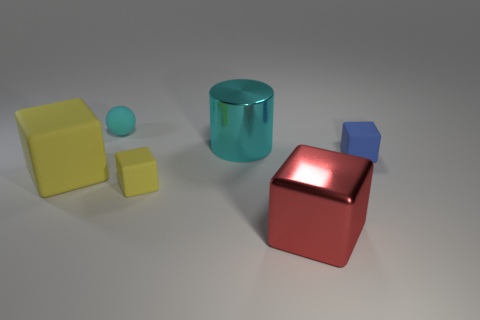Are there more tiny gray cylinders than metal objects?
Offer a terse response. No. How many cubes are both on the left side of the cyan matte ball and right of the big rubber object?
Offer a very short reply. 0. There is a large metallic object behind the blue matte thing; how many large blocks are left of it?
Offer a terse response. 1. What number of things are rubber things that are to the right of the tiny cyan rubber thing or small cubes to the left of the large red metal thing?
Make the answer very short. 2. What material is the blue thing that is the same shape as the big yellow object?
Your answer should be compact. Rubber. How many objects are either tiny matte cubes right of the cyan metallic cylinder or big yellow rubber blocks?
Your answer should be compact. 2. What shape is the other big object that is made of the same material as the big cyan object?
Make the answer very short. Cube. What number of tiny rubber things have the same shape as the big yellow thing?
Your answer should be compact. 2. What is the material of the large red thing?
Your response must be concise. Metal. Is the color of the tiny ball the same as the rubber cube that is left of the tiny matte sphere?
Give a very brief answer. No. 